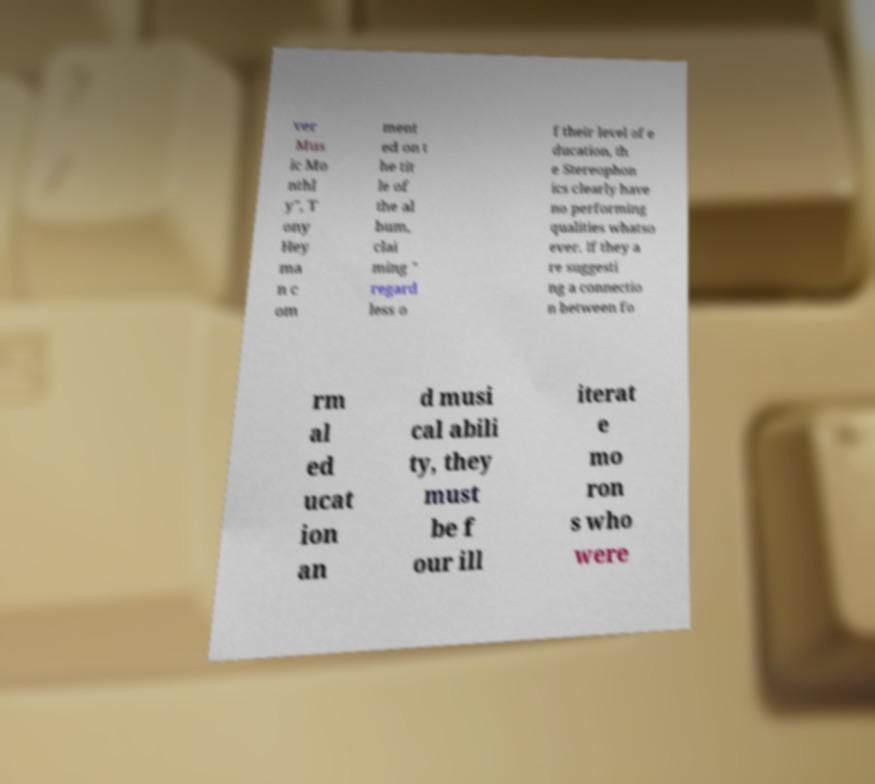I need the written content from this picture converted into text. Can you do that? ver Mus ic Mo nthl y", T ony Hey ma n c om ment ed on t he tit le of the al bum, clai ming " regard less o f their level of e ducation, th e Stereophon ics clearly have no performing qualities whatso ever. If they a re suggesti ng a connectio n between fo rm al ed ucat ion an d musi cal abili ty, they must be f our ill iterat e mo ron s who were 